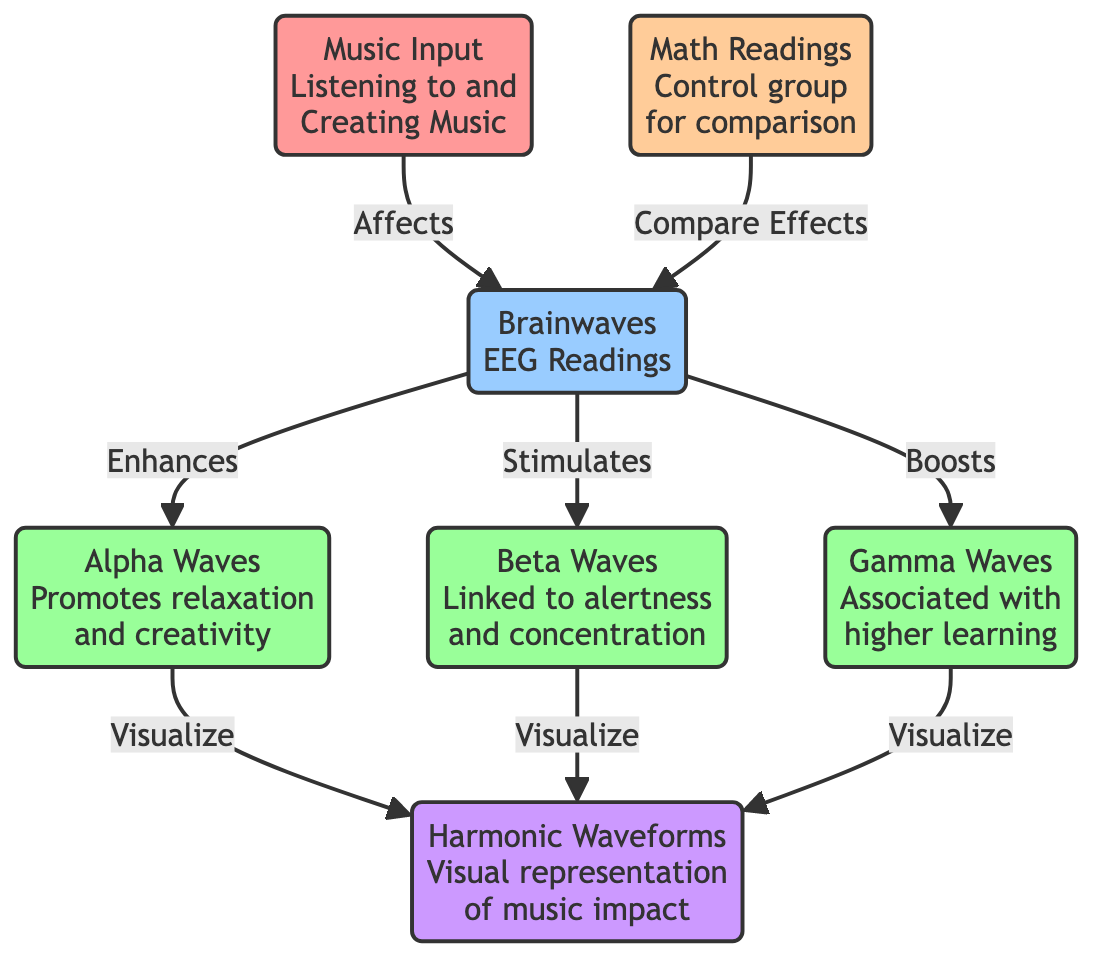What is the input to the diagram? The diagram starts with the node labeled "Music Input," which indicates that the input consists of listening to and creating music.
Answer: Music Input How many types of brainwaves are identified in the diagram? There are three types of brainwaves identified: alpha waves, beta waves, and gamma waves. Counting these nodes, we can see all three are explicitly mentioned in the outputs.
Answer: Three What effect does music have on alpha waves? The diagram indicates that music enhances alpha waves, suggesting that listening to or creating music promotes relaxation and creativity, as labeled next to the node.
Answer: Enhances What is used as a comparison group in the diagram? The diagram shows a node labeled "Math Readings," which serves as a control group for comparing the effects on brainwaves caused by music.
Answer: Math Readings How are the effects of brainwaves visually represented? The effects of the different types of brainwaves (alpha, beta, gamma) are visualized in the diagram through the node labeled "Harmonic Waveforms." This indicates that their impacts can be graphically shown.
Answer: Harmonic Waveforms Which brainwave type is associated with higher learning? According to the labels in the diagram, gamma waves are associated with higher learning and are affected by the music input.
Answer: Gamma Waves What relationship is indicated between math readings and brainwaves? The diagram indicates that math readings compare effects on brainwaves, establishing that there is a comparative relationship shown between these two nodes.
Answer: Compare Effects Which brainwave type is linked to alertness? The diagram specifies that beta waves are linked to alertness and concentration as indicated in the label next to the beta waves node.
Answer: Beta Waves What is the overall impact of music as described in the diagram? The overall impact of music is illustrated as affecting brainwaves, which leads to various states represented by alpha, beta, and gamma waves. The influence is primarily described as an enhancement or stimulation of these brain states.
Answer: Affects Brainwaves 